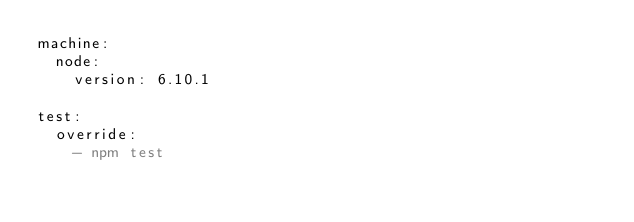<code> <loc_0><loc_0><loc_500><loc_500><_YAML_>machine:
  node:
    version: 6.10.1

test:
  override:
    - npm test
</code> 